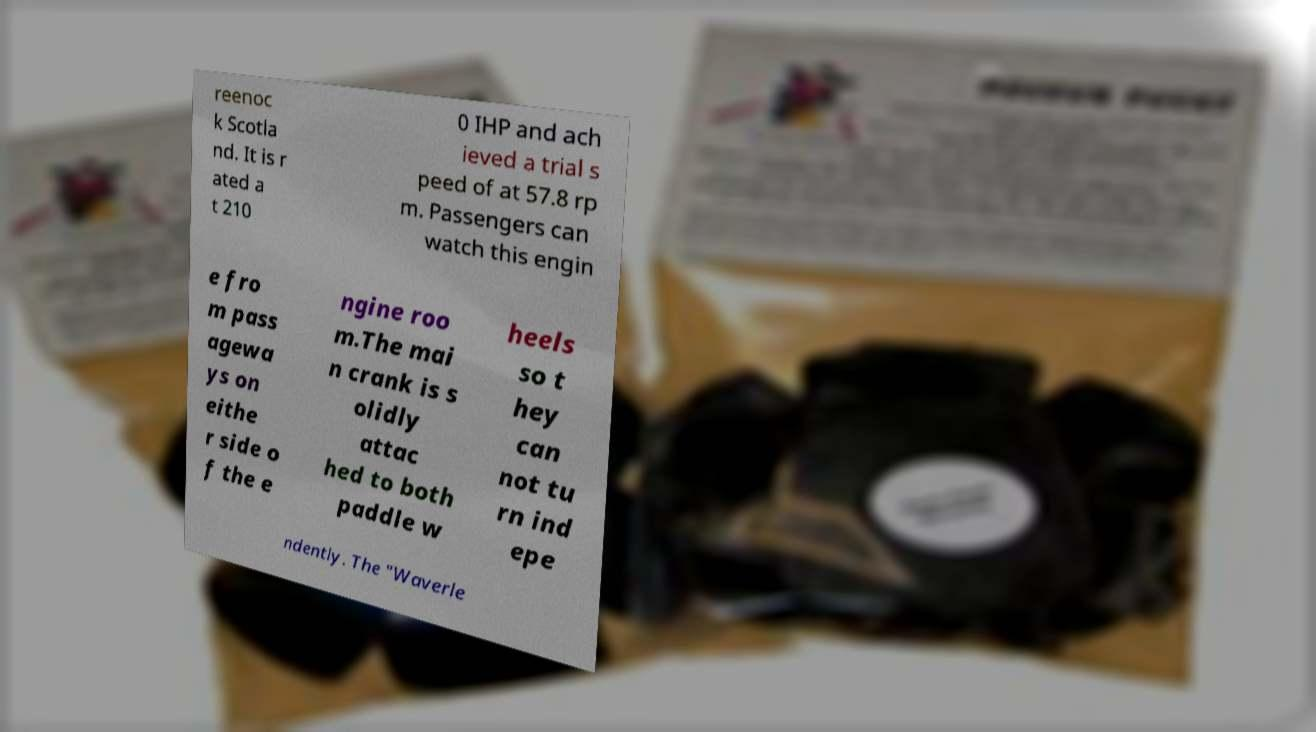Can you read and provide the text displayed in the image?This photo seems to have some interesting text. Can you extract and type it out for me? reenoc k Scotla nd. It is r ated a t 210 0 IHP and ach ieved a trial s peed of at 57.8 rp m. Passengers can watch this engin e fro m pass agewa ys on eithe r side o f the e ngine roo m.The mai n crank is s olidly attac hed to both paddle w heels so t hey can not tu rn ind epe ndently. The "Waverle 